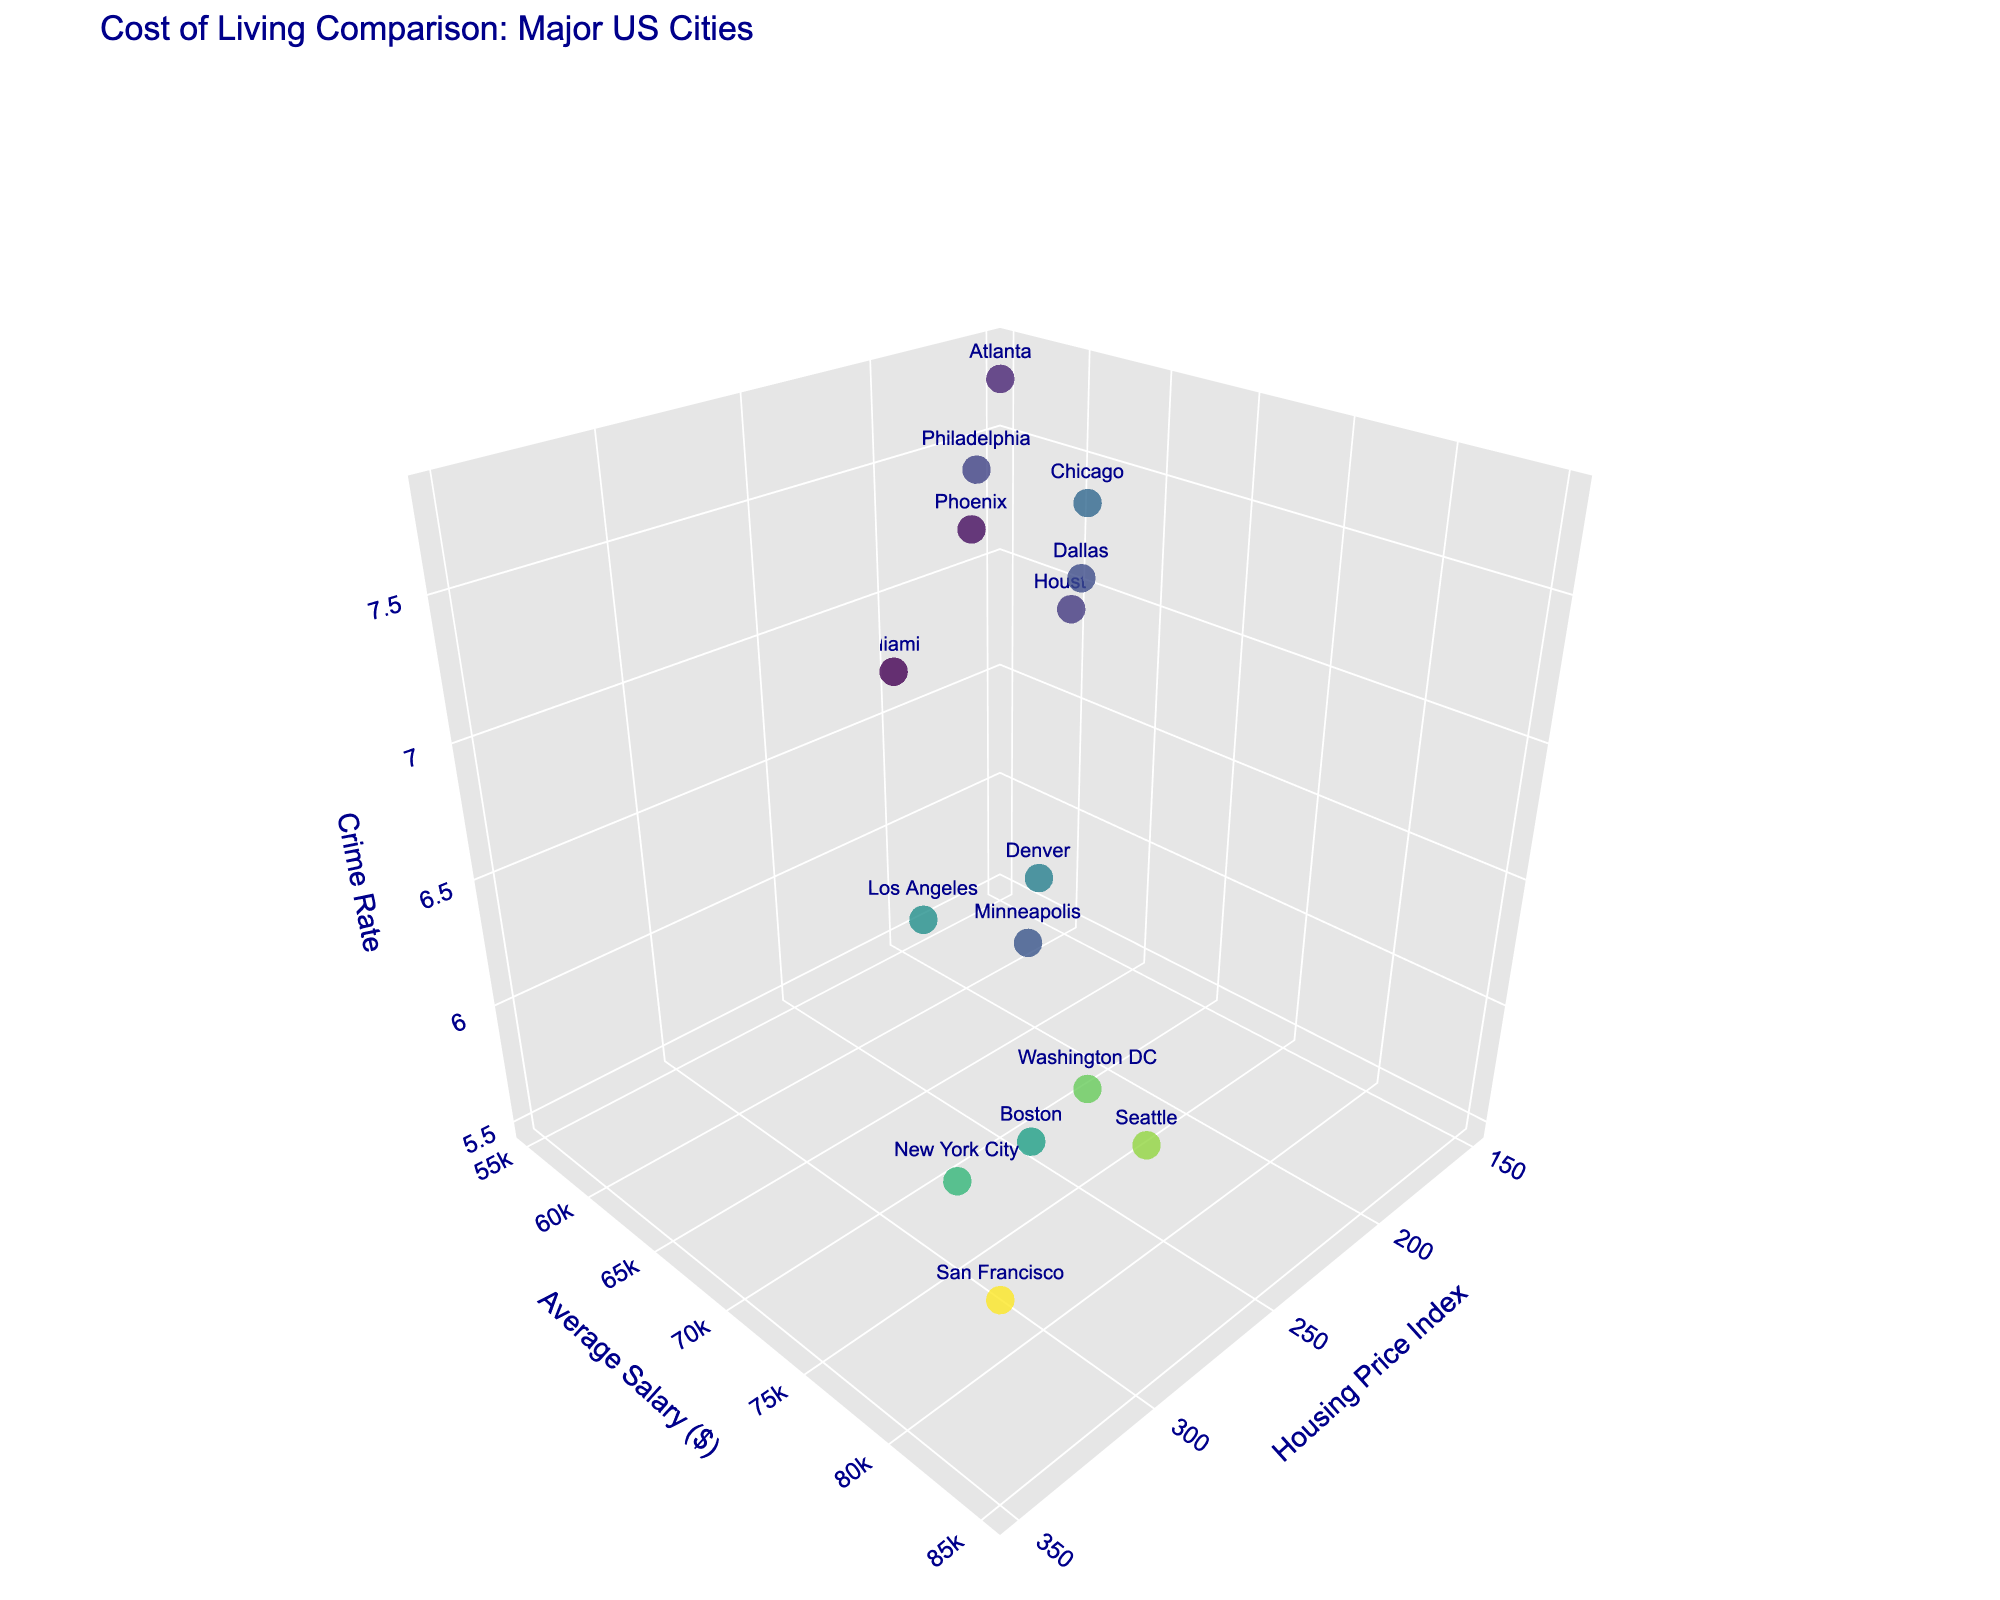How many data points are represented in the figure? The figure displays data for each city available in the dataset. You can count the number of cities listed under the "City" column to determine the number of data points.
Answer: 15 Which city has the highest housing price index? The Housing Price Index (x-axis) is labeled and can be seen on the scatter plot. By comparing the x-values, you can identify the city with the highest Housing Price Index. This city is San Francisco with an index of 350.
Answer: San Francisco Which city has the lowest average salary? The Average Salary (y-axis) is labeled and represented on the scatter plot. By comparing the y-values of each data point, the city with the lowest average salary is Miami with a salary of $55,000.
Answer: Miami Is there a city with a lower crime rate than New York City and similar average salary? First, identify New York City's crime rate and average salary on the plot. Then look for other cities with a lower crime rate and average salary close to $75,000. Boston fits this description with a crime rate of 5.5 and an average salary of $72,000.
Answer: Boston Which cities have an average salary between $60,000 and $70,000 and a crime rate above 7? Check the y-axis for salaries in the $60,000 - $70,000 range and then find corresponding cities with a z-value (crime rate) above 7. The cities that fit are Chicago with $65,000 and crime rate of 7.5, Dallas with $62,000 and crime rate of 7.1, Atlanta with $58,000 and crime rate of 7.8, Phoenix with $56,000 and crime rate of 7.2, and Philadelphia with $61,000 and crime rate of 7.6.
Answer: Chicago, Dallas, Atlanta, Phoenix, Philadelphia Among the cities with the highest average salaries, which one has the lowest crime rate? Identify the cities with the highest y-values (representing Average Salary) and compare their z-values (Crime Rates). Seattle has an average salary of $80,000 and a crime rate of 5.9. Washington DC has a slightly lower crime rate of 6.1, while San Francisco has the highest average salary but a higher crime rate of 6.2. Hence, Seattle has the lowest crime rate among the highest earning cities.
Answer: Seattle Which city lies closest to the origin (lowest values for all three metrics)? The origin represents the lowest values for Housing Price Index, Average Salary, and Crime Rate. Examine for the city with the lowest combination of x, y, and z values. Miami lies closest with Housing Price Index of 200, Average Salary of $55,000, and Crime Rate of 6.7.
Answer: Miami What is the difference in average salary between Seattle and Boston? Identify the y-values for both cities, Seattle (80,000) and Boston (72,000). Subtract Boston's salary from Seattle's salary to find the difference. 80,000 - 72,000 = 8,000.
Answer: 8,000 Does any city have both a high housing price index and a low crime rate? Assess cities of high Housing Price Index (high x-values) and check their crime rates (z-values). For instance, New York City with Housing Price Index of 300 and a crime rate of 5.8, and Boston with Housing Price Index 250 and crime rate of 5.5 correspond to high housing price combined with low crime rates comparatively.
Answer: New York City, Boston 